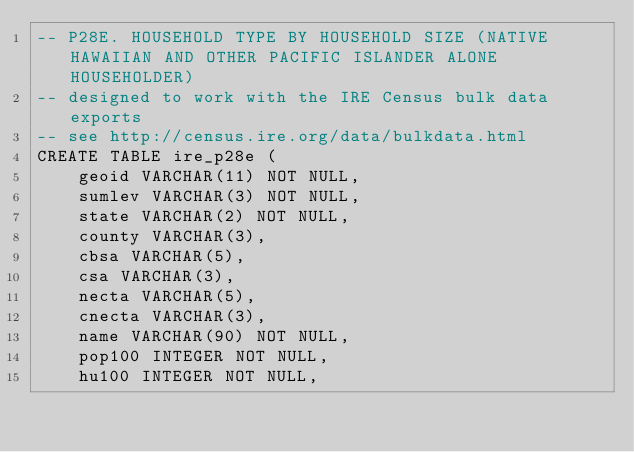Convert code to text. <code><loc_0><loc_0><loc_500><loc_500><_SQL_>-- P28E. HOUSEHOLD TYPE BY HOUSEHOLD SIZE (NATIVE HAWAIIAN AND OTHER PACIFIC ISLANDER ALONE HOUSEHOLDER)
-- designed to work with the IRE Census bulk data exports
-- see http://census.ire.org/data/bulkdata.html
CREATE TABLE ire_p28e (
	geoid VARCHAR(11) NOT NULL, 
	sumlev VARCHAR(3) NOT NULL, 
	state VARCHAR(2) NOT NULL, 
	county VARCHAR(3), 
	cbsa VARCHAR(5), 
	csa VARCHAR(3), 
	necta VARCHAR(5), 
	cnecta VARCHAR(3), 
	name VARCHAR(90) NOT NULL, 
	pop100 INTEGER NOT NULL, 
	hu100 INTEGER NOT NULL, </code> 